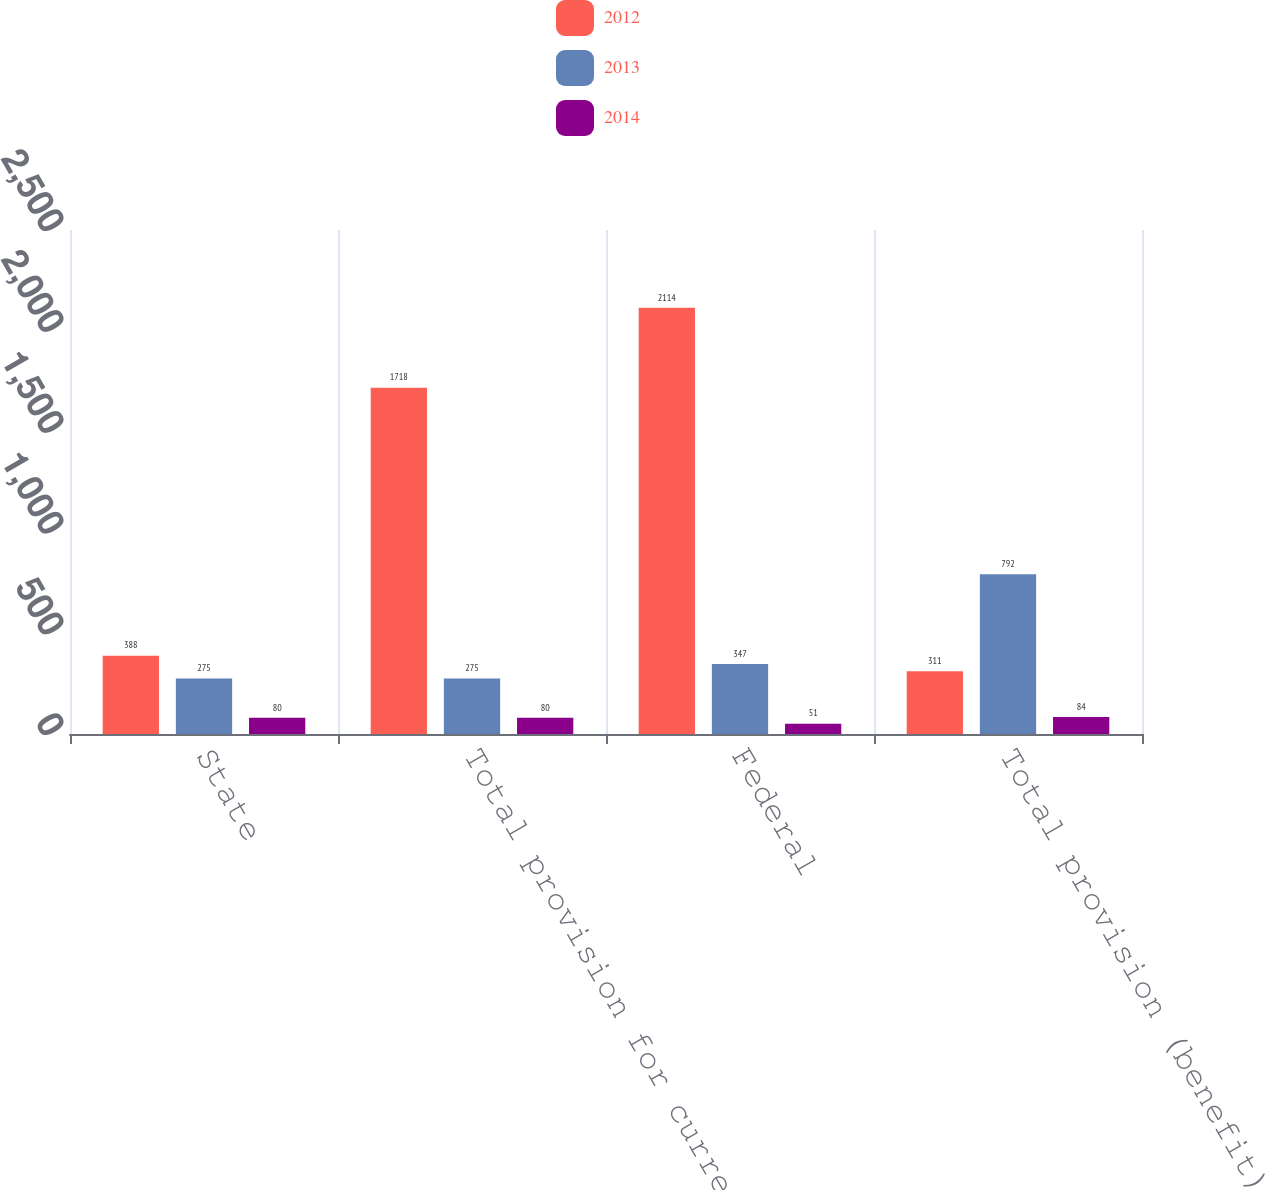<chart> <loc_0><loc_0><loc_500><loc_500><stacked_bar_chart><ecel><fcel>State<fcel>Total provision for current<fcel>Federal<fcel>Total provision (benefit) for<nl><fcel>2012<fcel>388<fcel>1718<fcel>2114<fcel>311<nl><fcel>2013<fcel>275<fcel>275<fcel>347<fcel>792<nl><fcel>2014<fcel>80<fcel>80<fcel>51<fcel>84<nl></chart> 